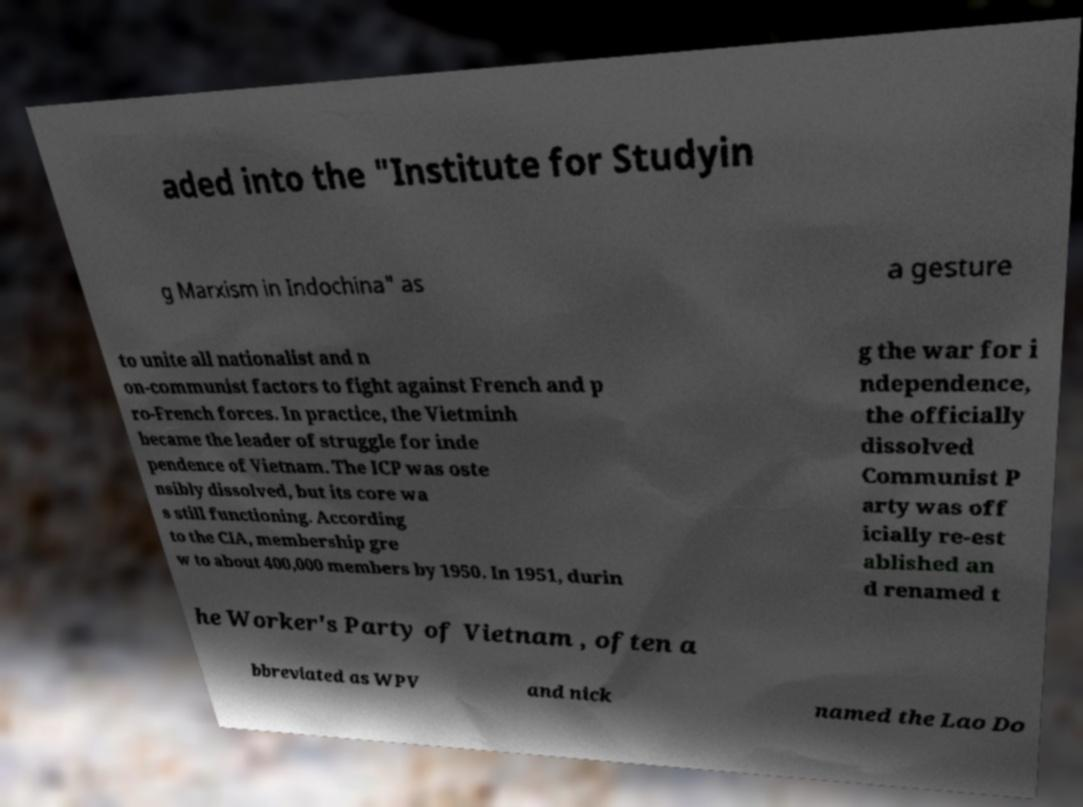I need the written content from this picture converted into text. Can you do that? aded into the "Institute for Studyin g Marxism in Indochina" as a gesture to unite all nationalist and n on-communist factors to fight against French and p ro-French forces. In practice, the Vietminh became the leader of struggle for inde pendence of Vietnam. The ICP was oste nsibly dissolved, but its core wa s still functioning. According to the CIA, membership gre w to about 400,000 members by 1950. In 1951, durin g the war for i ndependence, the officially dissolved Communist P arty was off icially re-est ablished an d renamed t he Worker's Party of Vietnam , often a bbreviated as WPV and nick named the Lao Do 